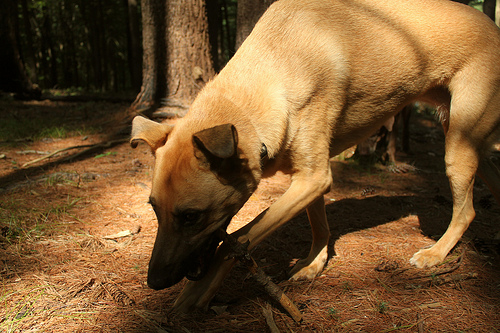<image>
Is the tree to the right of the dog? Yes. From this viewpoint, the tree is positioned to the right side relative to the dog. Is the dog in front of the tree? Yes. The dog is positioned in front of the tree, appearing closer to the camera viewpoint. 